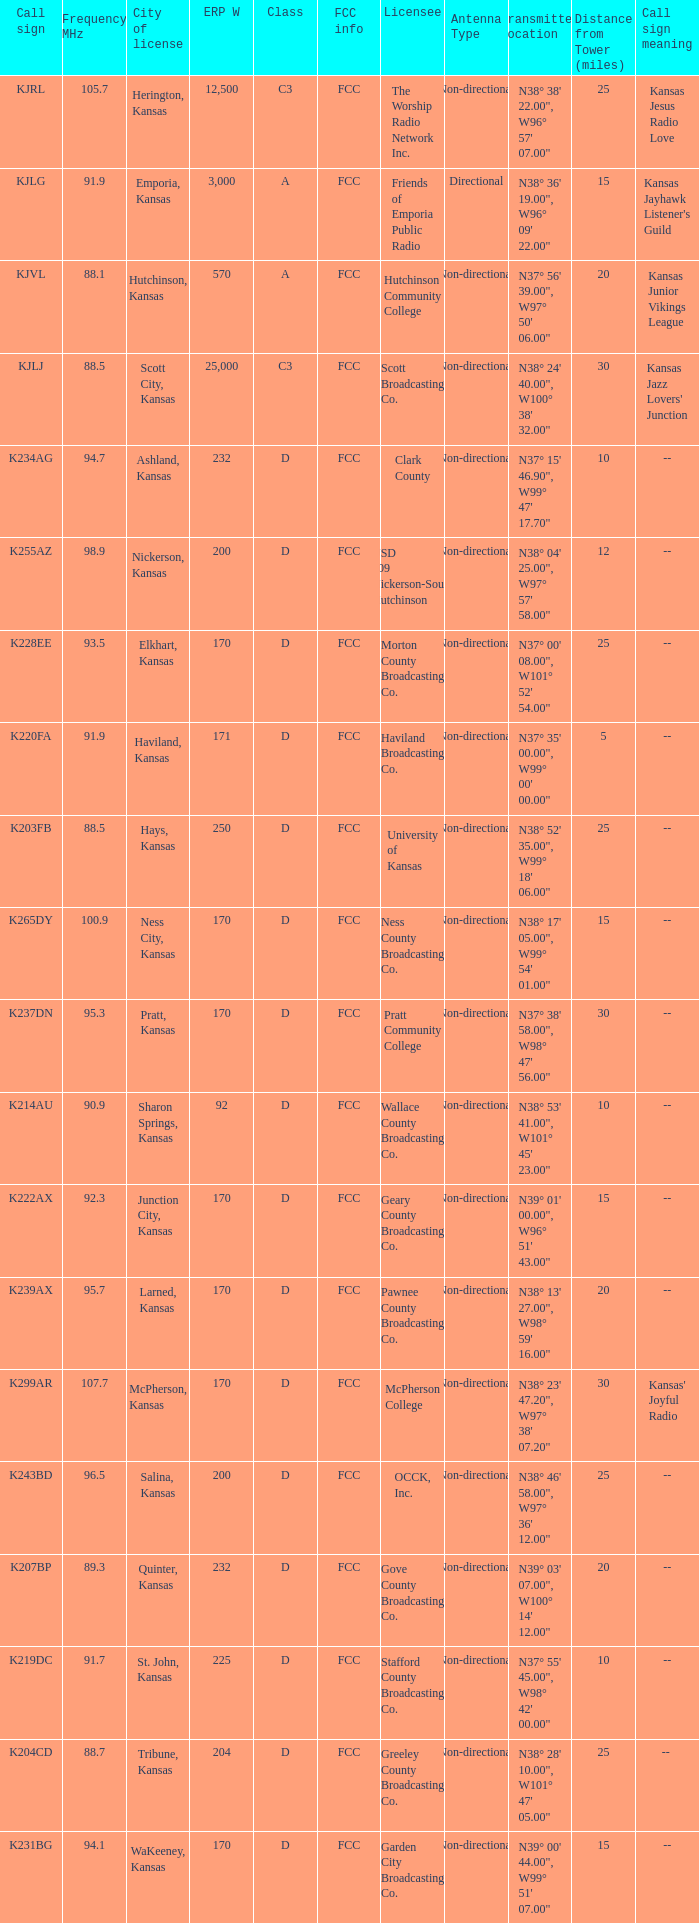ERP W that has a Class of d, and a Call sign of k299ar is what total number? 1.0. 